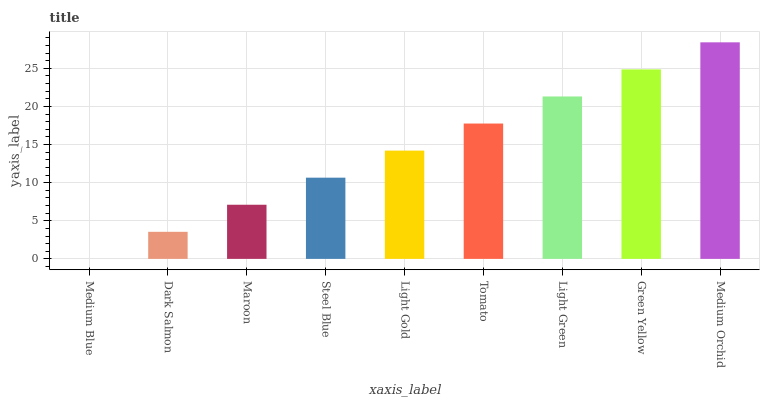Is Medium Blue the minimum?
Answer yes or no. Yes. Is Medium Orchid the maximum?
Answer yes or no. Yes. Is Dark Salmon the minimum?
Answer yes or no. No. Is Dark Salmon the maximum?
Answer yes or no. No. Is Dark Salmon greater than Medium Blue?
Answer yes or no. Yes. Is Medium Blue less than Dark Salmon?
Answer yes or no. Yes. Is Medium Blue greater than Dark Salmon?
Answer yes or no. No. Is Dark Salmon less than Medium Blue?
Answer yes or no. No. Is Light Gold the high median?
Answer yes or no. Yes. Is Light Gold the low median?
Answer yes or no. Yes. Is Maroon the high median?
Answer yes or no. No. Is Green Yellow the low median?
Answer yes or no. No. 